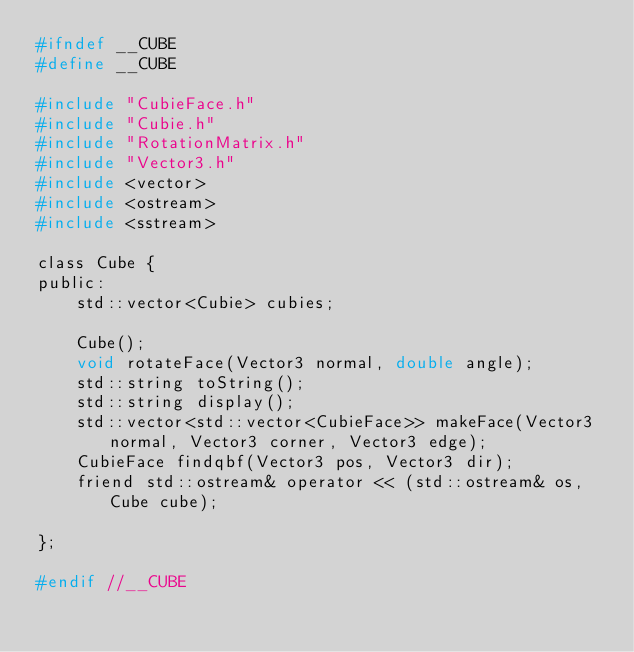Convert code to text. <code><loc_0><loc_0><loc_500><loc_500><_C_>#ifndef __CUBE
#define __CUBE

#include "CubieFace.h"
#include "Cubie.h"
#include "RotationMatrix.h"
#include "Vector3.h"
#include <vector>
#include <ostream>
#include <sstream>

class Cube {
public:
    std::vector<Cubie> cubies;

    Cube();
    void rotateFace(Vector3 normal, double angle);
    std::string toString();
    std::string display();
    std::vector<std::vector<CubieFace>> makeFace(Vector3 normal, Vector3 corner, Vector3 edge);
    CubieFace findqbf(Vector3 pos, Vector3 dir);
    friend std::ostream& operator << (std::ostream& os, Cube cube);

};

#endif //__CUBE
</code> 